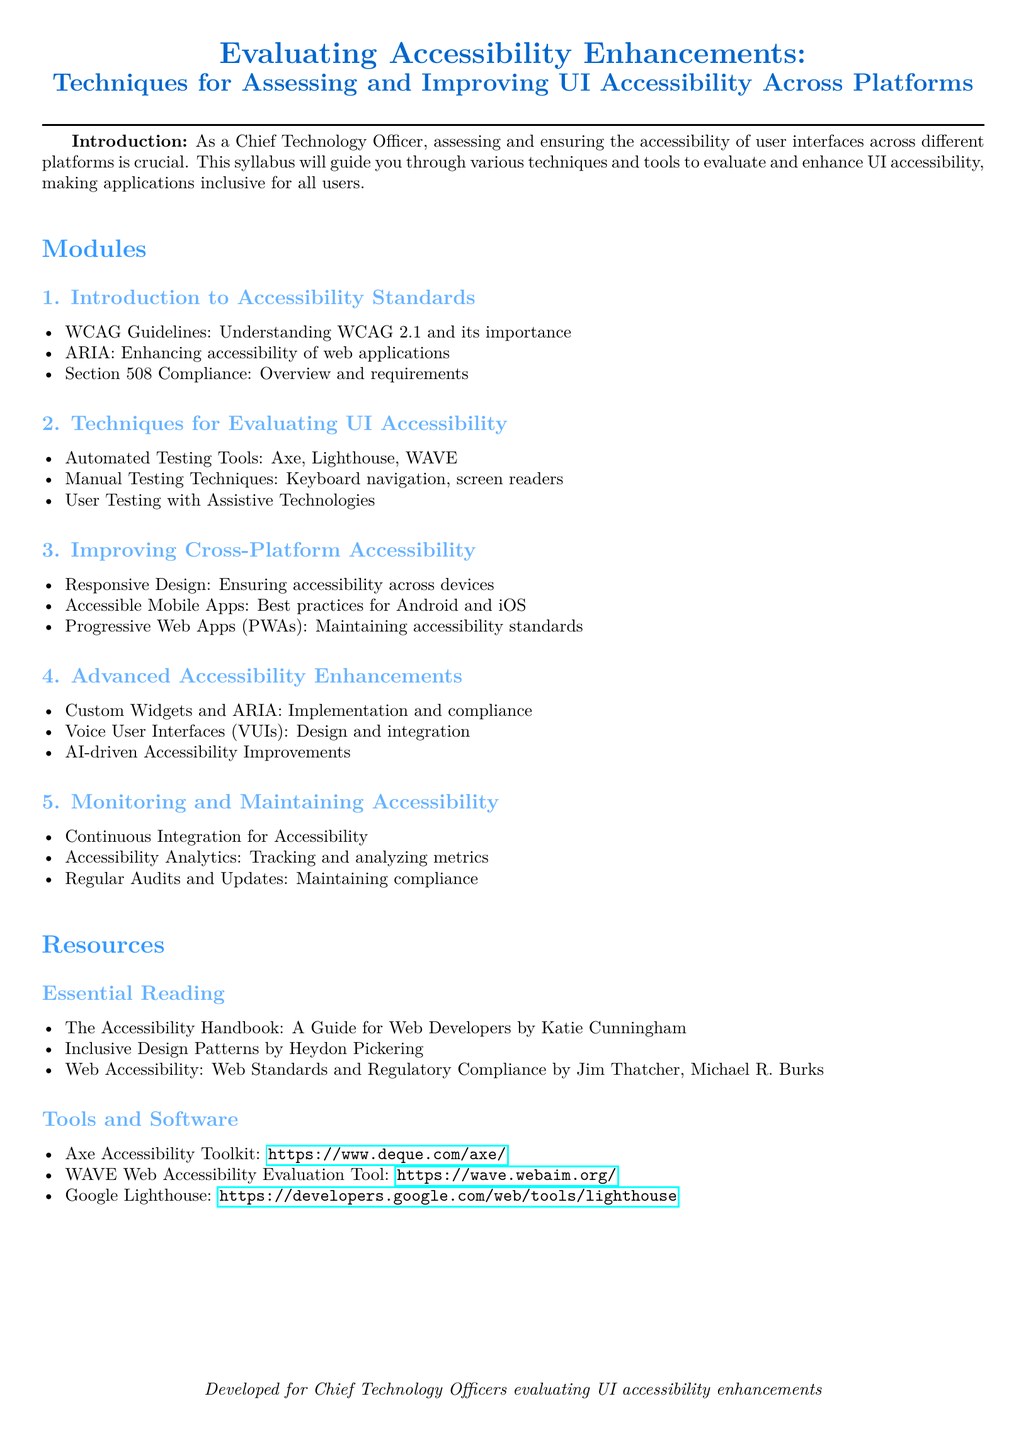What are the WCAG Guidelines? WCAG Guidelines refer to the Web Content Accessibility Guidelines, which are standards for making web content more accessible.
Answer: Web Content Accessibility Guidelines What tools are listed for automated testing? The document lists specific automated testing tools that can be used to evaluate UI accessibility.
Answer: Axe, Lighthouse, WAVE What is the focus of Section 3? The focus of Section 3 is on improving accessibility across different platforms, including strategies and practices.
Answer: Improving Cross-Platform Accessibility What is one of the advanced accessibility enhancements mentioned? The document mentions various advanced enhancements aimed at improving UI accessibility; one example can be found within the section list.
Answer: Voice User Interfaces How many modules are outlined in the syllabus? The syllabus is organized into multiple modules that cover different aspects of accessibility enhancements.
Answer: Five modules 